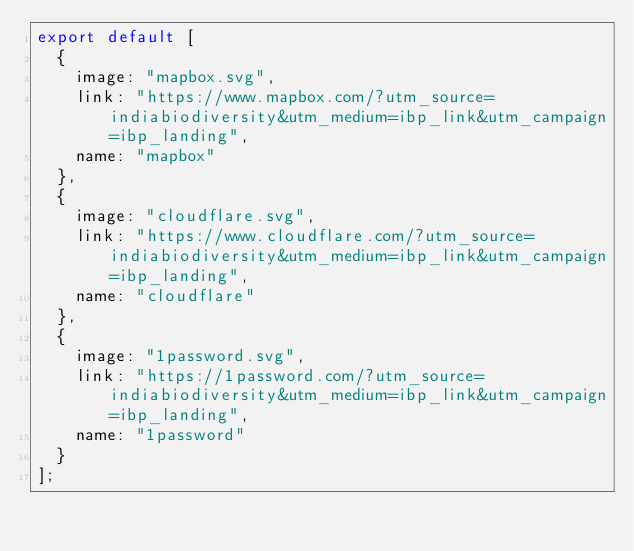Convert code to text. <code><loc_0><loc_0><loc_500><loc_500><_TypeScript_>export default [
  {
    image: "mapbox.svg",
    link: "https://www.mapbox.com/?utm_source=indiabiodiversity&utm_medium=ibp_link&utm_campaign=ibp_landing",
    name: "mapbox"
  },
  {
    image: "cloudflare.svg",
    link: "https://www.cloudflare.com/?utm_source=indiabiodiversity&utm_medium=ibp_link&utm_campaign=ibp_landing",
    name: "cloudflare"
  },
  {
    image: "1password.svg",
    link: "https://1password.com/?utm_source=indiabiodiversity&utm_medium=ibp_link&utm_campaign=ibp_landing",
    name: "1password"
  }
];
</code> 